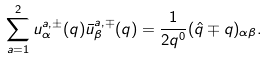Convert formula to latex. <formula><loc_0><loc_0><loc_500><loc_500>\sum _ { a = 1 } ^ { 2 } u ^ { a , \pm } _ { \alpha } ( q ) \bar { u } ^ { a , \mp } _ { \beta } ( q ) = \frac { 1 } { 2 q ^ { 0 } } ( \hat { q } \mp q ) _ { \alpha \beta } .</formula> 